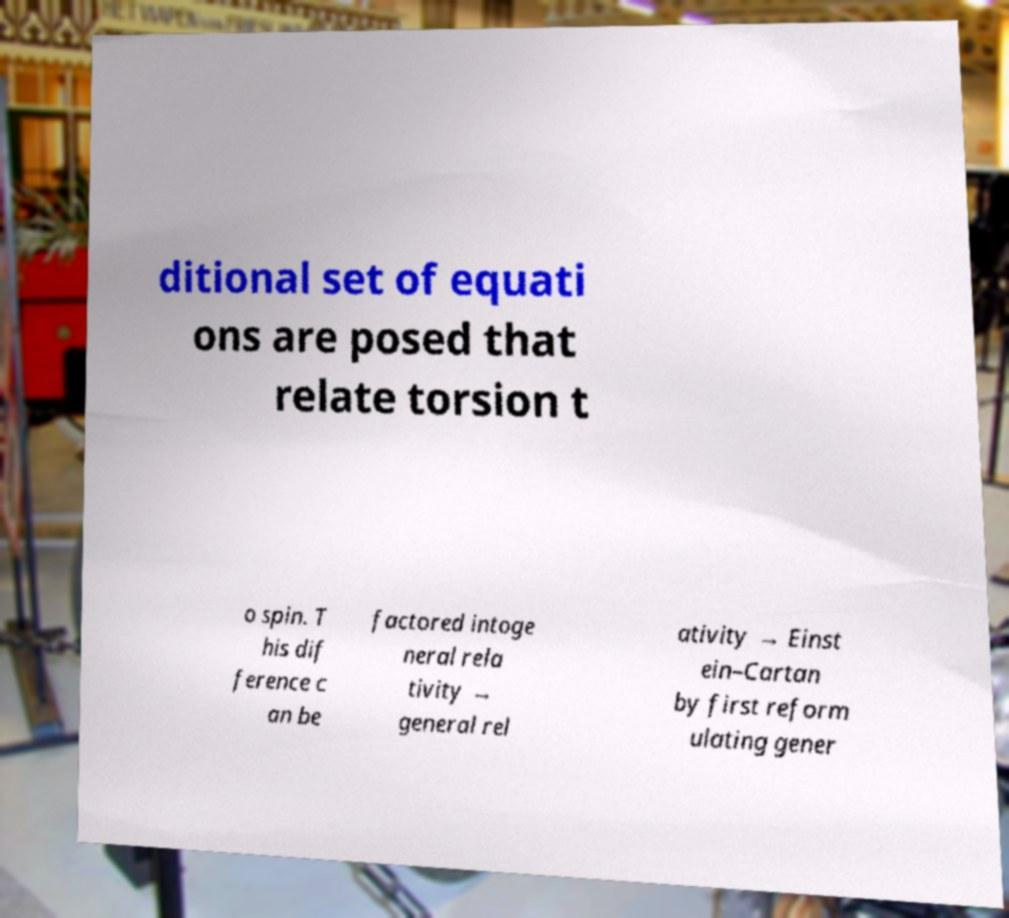Please read and relay the text visible in this image. What does it say? ditional set of equati ons are posed that relate torsion t o spin. T his dif ference c an be factored intoge neral rela tivity → general rel ativity → Einst ein–Cartan by first reform ulating gener 